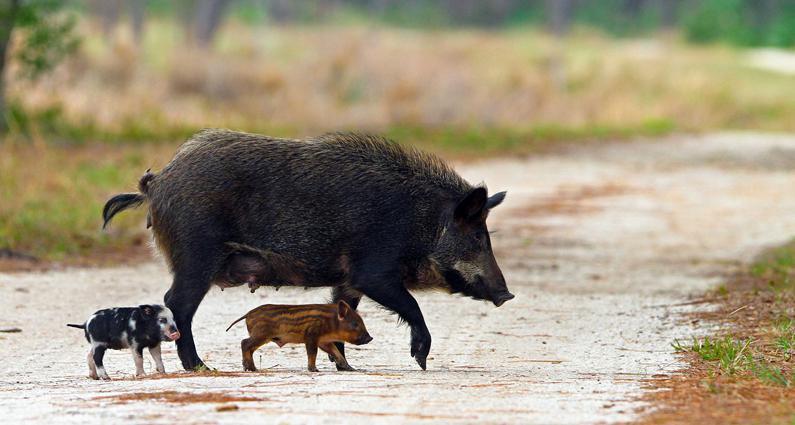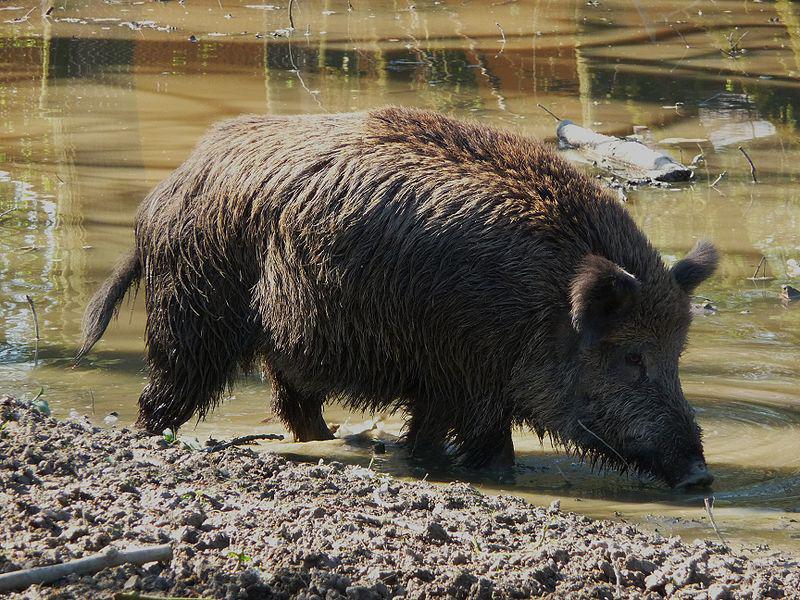The first image is the image on the left, the second image is the image on the right. Considering the images on both sides, is "There are baby boars in the image on the left." valid? Answer yes or no. Yes. 